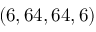<formula> <loc_0><loc_0><loc_500><loc_500>( 6 , 6 4 , 6 4 , 6 )</formula> 